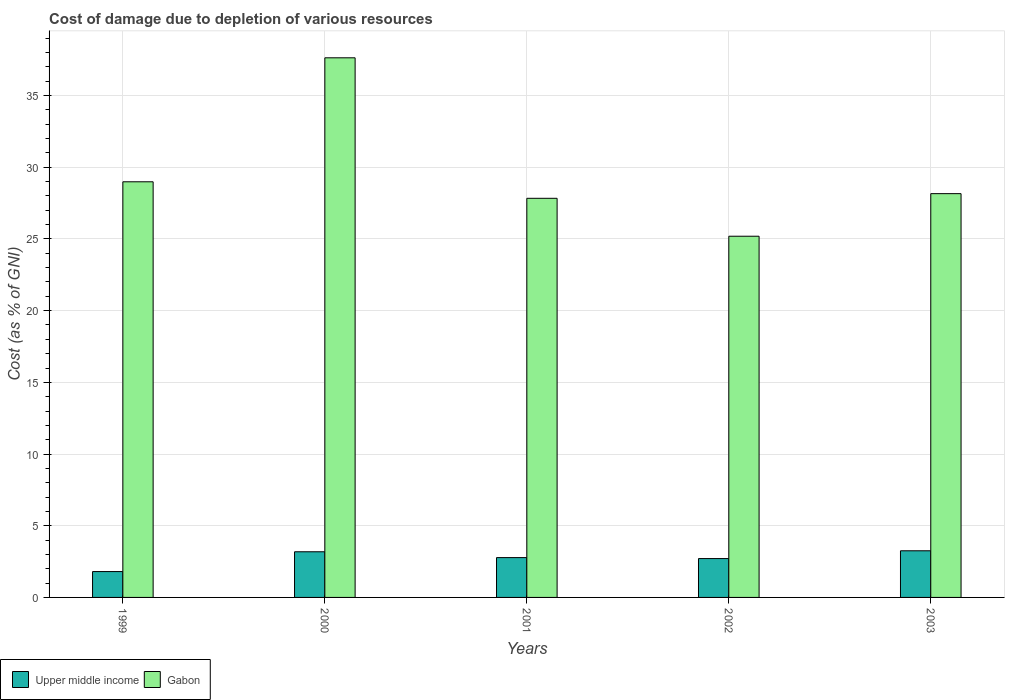How many different coloured bars are there?
Offer a very short reply. 2. How many groups of bars are there?
Your response must be concise. 5. Are the number of bars per tick equal to the number of legend labels?
Offer a terse response. Yes. Are the number of bars on each tick of the X-axis equal?
Your answer should be compact. Yes. How many bars are there on the 4th tick from the right?
Your answer should be very brief. 2. In how many cases, is the number of bars for a given year not equal to the number of legend labels?
Provide a succinct answer. 0. What is the cost of damage caused due to the depletion of various resources in Upper middle income in 1999?
Your answer should be compact. 1.8. Across all years, what is the maximum cost of damage caused due to the depletion of various resources in Upper middle income?
Your answer should be compact. 3.25. Across all years, what is the minimum cost of damage caused due to the depletion of various resources in Upper middle income?
Offer a very short reply. 1.8. In which year was the cost of damage caused due to the depletion of various resources in Gabon minimum?
Keep it short and to the point. 2002. What is the total cost of damage caused due to the depletion of various resources in Gabon in the graph?
Provide a succinct answer. 147.81. What is the difference between the cost of damage caused due to the depletion of various resources in Upper middle income in 1999 and that in 2002?
Give a very brief answer. -0.91. What is the difference between the cost of damage caused due to the depletion of various resources in Gabon in 2000 and the cost of damage caused due to the depletion of various resources in Upper middle income in 2003?
Make the answer very short. 34.38. What is the average cost of damage caused due to the depletion of various resources in Upper middle income per year?
Offer a terse response. 2.75. In the year 2003, what is the difference between the cost of damage caused due to the depletion of various resources in Gabon and cost of damage caused due to the depletion of various resources in Upper middle income?
Your answer should be compact. 24.91. In how many years, is the cost of damage caused due to the depletion of various resources in Gabon greater than 32 %?
Your answer should be compact. 1. What is the ratio of the cost of damage caused due to the depletion of various resources in Upper middle income in 1999 to that in 2000?
Make the answer very short. 0.57. What is the difference between the highest and the second highest cost of damage caused due to the depletion of various resources in Upper middle income?
Give a very brief answer. 0.07. What is the difference between the highest and the lowest cost of damage caused due to the depletion of various resources in Gabon?
Make the answer very short. 12.44. What does the 2nd bar from the left in 2002 represents?
Make the answer very short. Gabon. What does the 1st bar from the right in 2003 represents?
Keep it short and to the point. Gabon. How many bars are there?
Provide a short and direct response. 10. How many years are there in the graph?
Provide a short and direct response. 5. What is the difference between two consecutive major ticks on the Y-axis?
Your response must be concise. 5. Does the graph contain any zero values?
Keep it short and to the point. No. Does the graph contain grids?
Your response must be concise. Yes. Where does the legend appear in the graph?
Keep it short and to the point. Bottom left. How are the legend labels stacked?
Offer a very short reply. Horizontal. What is the title of the graph?
Your answer should be compact. Cost of damage due to depletion of various resources. Does "Low & middle income" appear as one of the legend labels in the graph?
Offer a very short reply. No. What is the label or title of the X-axis?
Keep it short and to the point. Years. What is the label or title of the Y-axis?
Provide a short and direct response. Cost (as % of GNI). What is the Cost (as % of GNI) of Upper middle income in 1999?
Ensure brevity in your answer.  1.8. What is the Cost (as % of GNI) of Gabon in 1999?
Give a very brief answer. 28.99. What is the Cost (as % of GNI) in Upper middle income in 2000?
Your answer should be very brief. 3.18. What is the Cost (as % of GNI) of Gabon in 2000?
Your answer should be compact. 37.63. What is the Cost (as % of GNI) in Upper middle income in 2001?
Ensure brevity in your answer.  2.78. What is the Cost (as % of GNI) in Gabon in 2001?
Your answer should be very brief. 27.83. What is the Cost (as % of GNI) in Upper middle income in 2002?
Offer a very short reply. 2.71. What is the Cost (as % of GNI) in Gabon in 2002?
Your answer should be very brief. 25.19. What is the Cost (as % of GNI) of Upper middle income in 2003?
Provide a succinct answer. 3.25. What is the Cost (as % of GNI) of Gabon in 2003?
Provide a succinct answer. 28.16. Across all years, what is the maximum Cost (as % of GNI) in Upper middle income?
Your answer should be compact. 3.25. Across all years, what is the maximum Cost (as % of GNI) in Gabon?
Ensure brevity in your answer.  37.63. Across all years, what is the minimum Cost (as % of GNI) of Upper middle income?
Offer a terse response. 1.8. Across all years, what is the minimum Cost (as % of GNI) of Gabon?
Make the answer very short. 25.19. What is the total Cost (as % of GNI) of Upper middle income in the graph?
Your response must be concise. 13.73. What is the total Cost (as % of GNI) in Gabon in the graph?
Give a very brief answer. 147.81. What is the difference between the Cost (as % of GNI) in Upper middle income in 1999 and that in 2000?
Your answer should be compact. -1.38. What is the difference between the Cost (as % of GNI) in Gabon in 1999 and that in 2000?
Give a very brief answer. -8.65. What is the difference between the Cost (as % of GNI) of Upper middle income in 1999 and that in 2001?
Your response must be concise. -0.97. What is the difference between the Cost (as % of GNI) in Gabon in 1999 and that in 2001?
Ensure brevity in your answer.  1.15. What is the difference between the Cost (as % of GNI) of Upper middle income in 1999 and that in 2002?
Keep it short and to the point. -0.91. What is the difference between the Cost (as % of GNI) in Gabon in 1999 and that in 2002?
Give a very brief answer. 3.8. What is the difference between the Cost (as % of GNI) in Upper middle income in 1999 and that in 2003?
Give a very brief answer. -1.45. What is the difference between the Cost (as % of GNI) in Gabon in 1999 and that in 2003?
Give a very brief answer. 0.83. What is the difference between the Cost (as % of GNI) of Upper middle income in 2000 and that in 2001?
Your answer should be very brief. 0.41. What is the difference between the Cost (as % of GNI) of Gabon in 2000 and that in 2001?
Provide a short and direct response. 9.8. What is the difference between the Cost (as % of GNI) in Upper middle income in 2000 and that in 2002?
Make the answer very short. 0.47. What is the difference between the Cost (as % of GNI) in Gabon in 2000 and that in 2002?
Offer a very short reply. 12.44. What is the difference between the Cost (as % of GNI) in Upper middle income in 2000 and that in 2003?
Your answer should be compact. -0.07. What is the difference between the Cost (as % of GNI) of Gabon in 2000 and that in 2003?
Keep it short and to the point. 9.47. What is the difference between the Cost (as % of GNI) of Upper middle income in 2001 and that in 2002?
Your answer should be compact. 0.07. What is the difference between the Cost (as % of GNI) of Gabon in 2001 and that in 2002?
Offer a terse response. 2.64. What is the difference between the Cost (as % of GNI) in Upper middle income in 2001 and that in 2003?
Your answer should be very brief. -0.47. What is the difference between the Cost (as % of GNI) of Gabon in 2001 and that in 2003?
Your response must be concise. -0.33. What is the difference between the Cost (as % of GNI) of Upper middle income in 2002 and that in 2003?
Provide a short and direct response. -0.54. What is the difference between the Cost (as % of GNI) of Gabon in 2002 and that in 2003?
Your answer should be very brief. -2.97. What is the difference between the Cost (as % of GNI) in Upper middle income in 1999 and the Cost (as % of GNI) in Gabon in 2000?
Offer a very short reply. -35.83. What is the difference between the Cost (as % of GNI) of Upper middle income in 1999 and the Cost (as % of GNI) of Gabon in 2001?
Make the answer very short. -26.03. What is the difference between the Cost (as % of GNI) of Upper middle income in 1999 and the Cost (as % of GNI) of Gabon in 2002?
Keep it short and to the point. -23.39. What is the difference between the Cost (as % of GNI) of Upper middle income in 1999 and the Cost (as % of GNI) of Gabon in 2003?
Make the answer very short. -26.36. What is the difference between the Cost (as % of GNI) in Upper middle income in 2000 and the Cost (as % of GNI) in Gabon in 2001?
Give a very brief answer. -24.65. What is the difference between the Cost (as % of GNI) of Upper middle income in 2000 and the Cost (as % of GNI) of Gabon in 2002?
Make the answer very short. -22.01. What is the difference between the Cost (as % of GNI) in Upper middle income in 2000 and the Cost (as % of GNI) in Gabon in 2003?
Your answer should be compact. -24.98. What is the difference between the Cost (as % of GNI) of Upper middle income in 2001 and the Cost (as % of GNI) of Gabon in 2002?
Keep it short and to the point. -22.41. What is the difference between the Cost (as % of GNI) in Upper middle income in 2001 and the Cost (as % of GNI) in Gabon in 2003?
Keep it short and to the point. -25.38. What is the difference between the Cost (as % of GNI) of Upper middle income in 2002 and the Cost (as % of GNI) of Gabon in 2003?
Your response must be concise. -25.45. What is the average Cost (as % of GNI) in Upper middle income per year?
Offer a very short reply. 2.75. What is the average Cost (as % of GNI) in Gabon per year?
Keep it short and to the point. 29.56. In the year 1999, what is the difference between the Cost (as % of GNI) in Upper middle income and Cost (as % of GNI) in Gabon?
Ensure brevity in your answer.  -27.18. In the year 2000, what is the difference between the Cost (as % of GNI) in Upper middle income and Cost (as % of GNI) in Gabon?
Give a very brief answer. -34.45. In the year 2001, what is the difference between the Cost (as % of GNI) in Upper middle income and Cost (as % of GNI) in Gabon?
Keep it short and to the point. -25.06. In the year 2002, what is the difference between the Cost (as % of GNI) of Upper middle income and Cost (as % of GNI) of Gabon?
Provide a short and direct response. -22.48. In the year 2003, what is the difference between the Cost (as % of GNI) in Upper middle income and Cost (as % of GNI) in Gabon?
Give a very brief answer. -24.91. What is the ratio of the Cost (as % of GNI) of Upper middle income in 1999 to that in 2000?
Your answer should be compact. 0.57. What is the ratio of the Cost (as % of GNI) in Gabon in 1999 to that in 2000?
Offer a terse response. 0.77. What is the ratio of the Cost (as % of GNI) of Upper middle income in 1999 to that in 2001?
Your answer should be compact. 0.65. What is the ratio of the Cost (as % of GNI) in Gabon in 1999 to that in 2001?
Offer a terse response. 1.04. What is the ratio of the Cost (as % of GNI) of Upper middle income in 1999 to that in 2002?
Keep it short and to the point. 0.67. What is the ratio of the Cost (as % of GNI) in Gabon in 1999 to that in 2002?
Keep it short and to the point. 1.15. What is the ratio of the Cost (as % of GNI) of Upper middle income in 1999 to that in 2003?
Ensure brevity in your answer.  0.55. What is the ratio of the Cost (as % of GNI) in Gabon in 1999 to that in 2003?
Make the answer very short. 1.03. What is the ratio of the Cost (as % of GNI) in Upper middle income in 2000 to that in 2001?
Offer a terse response. 1.15. What is the ratio of the Cost (as % of GNI) in Gabon in 2000 to that in 2001?
Make the answer very short. 1.35. What is the ratio of the Cost (as % of GNI) of Upper middle income in 2000 to that in 2002?
Your answer should be very brief. 1.17. What is the ratio of the Cost (as % of GNI) in Gabon in 2000 to that in 2002?
Make the answer very short. 1.49. What is the ratio of the Cost (as % of GNI) of Upper middle income in 2000 to that in 2003?
Make the answer very short. 0.98. What is the ratio of the Cost (as % of GNI) of Gabon in 2000 to that in 2003?
Offer a very short reply. 1.34. What is the ratio of the Cost (as % of GNI) in Gabon in 2001 to that in 2002?
Your answer should be very brief. 1.1. What is the ratio of the Cost (as % of GNI) in Upper middle income in 2001 to that in 2003?
Your answer should be very brief. 0.85. What is the ratio of the Cost (as % of GNI) in Upper middle income in 2002 to that in 2003?
Give a very brief answer. 0.83. What is the ratio of the Cost (as % of GNI) in Gabon in 2002 to that in 2003?
Ensure brevity in your answer.  0.89. What is the difference between the highest and the second highest Cost (as % of GNI) in Upper middle income?
Your answer should be compact. 0.07. What is the difference between the highest and the second highest Cost (as % of GNI) in Gabon?
Provide a short and direct response. 8.65. What is the difference between the highest and the lowest Cost (as % of GNI) of Upper middle income?
Provide a short and direct response. 1.45. What is the difference between the highest and the lowest Cost (as % of GNI) of Gabon?
Offer a terse response. 12.44. 